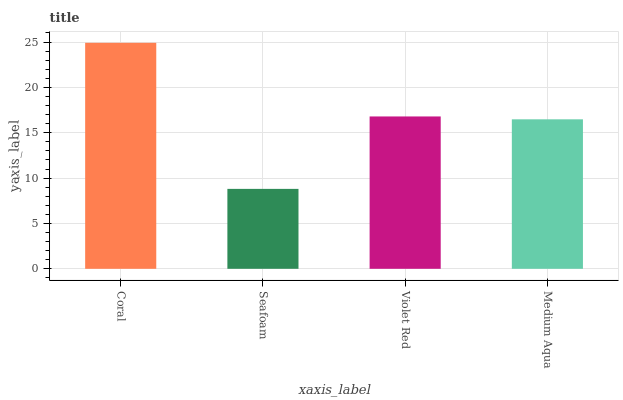Is Seafoam the minimum?
Answer yes or no. Yes. Is Coral the maximum?
Answer yes or no. Yes. Is Violet Red the minimum?
Answer yes or no. No. Is Violet Red the maximum?
Answer yes or no. No. Is Violet Red greater than Seafoam?
Answer yes or no. Yes. Is Seafoam less than Violet Red?
Answer yes or no. Yes. Is Seafoam greater than Violet Red?
Answer yes or no. No. Is Violet Red less than Seafoam?
Answer yes or no. No. Is Violet Red the high median?
Answer yes or no. Yes. Is Medium Aqua the low median?
Answer yes or no. Yes. Is Seafoam the high median?
Answer yes or no. No. Is Violet Red the low median?
Answer yes or no. No. 